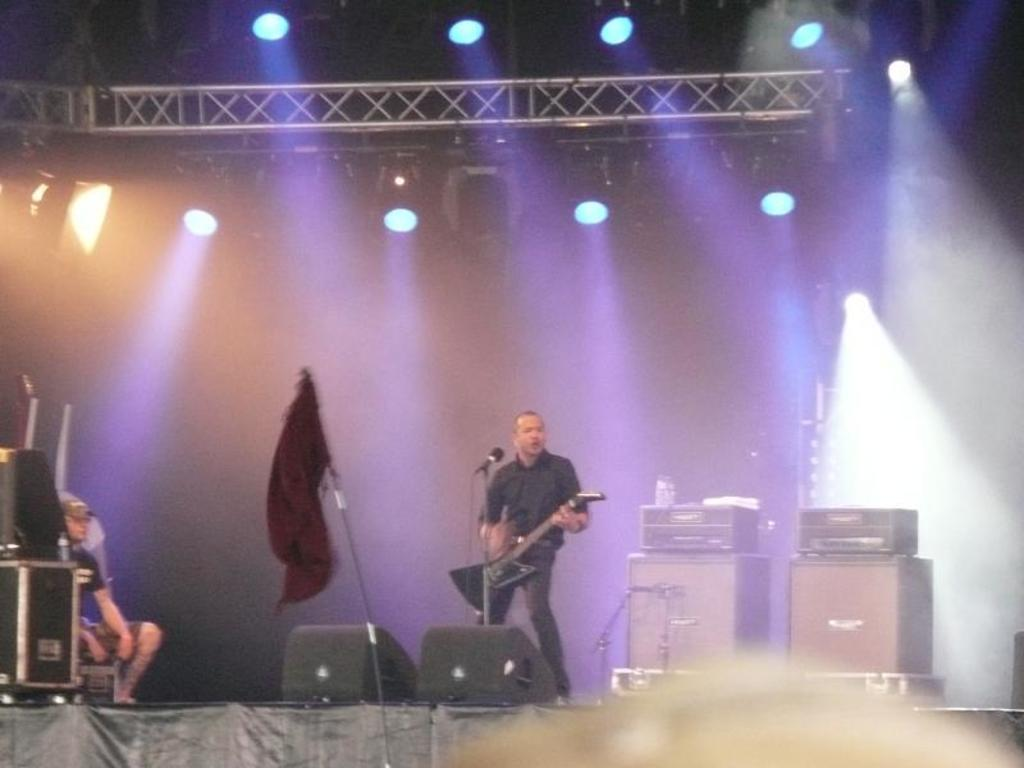What type of lights are present in the image? There are focusing lights in the image. What is the person on stage doing? The person is playing guitar on a stage. What objects can be seen in the image besides the lights and the person? There are devices visible in the image. How many people are present in the image? There is one person present in the image. What is the person holding in the image? The person is holding a microphone (mic) in the image. What additional object can be seen in the image? There is a flag in the image. What type of shoes is the person wearing while driving in the image? There is no person driving in the image, and no shoes are visible. What is the person doing to help the earth in the image? There is no indication of the person helping the earth in the image. 